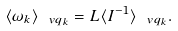<formula> <loc_0><loc_0><loc_500><loc_500>\langle \omega _ { k } \rangle _ { \ v q _ { k } } = L \langle I ^ { - 1 } \rangle _ { \ v q _ { k } } .</formula> 